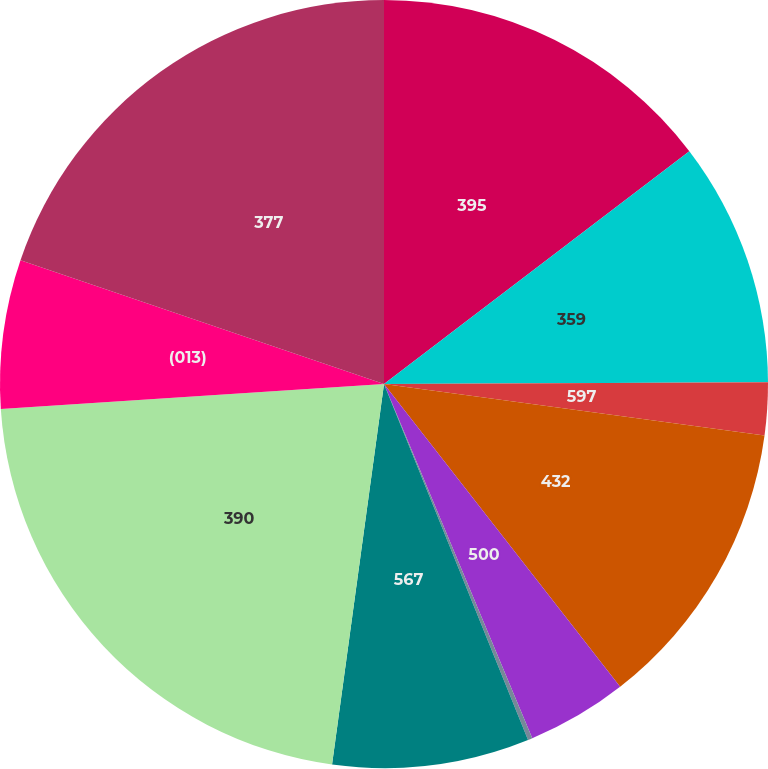Convert chart to OTSL. <chart><loc_0><loc_0><loc_500><loc_500><pie_chart><fcel>395<fcel>359<fcel>597<fcel>432<fcel>500<fcel>068<fcel>567<fcel>390<fcel>(013)<fcel>377<nl><fcel>14.63%<fcel>10.3%<fcel>2.21%<fcel>12.32%<fcel>4.23%<fcel>0.19%<fcel>8.28%<fcel>21.8%<fcel>6.26%<fcel>19.78%<nl></chart> 